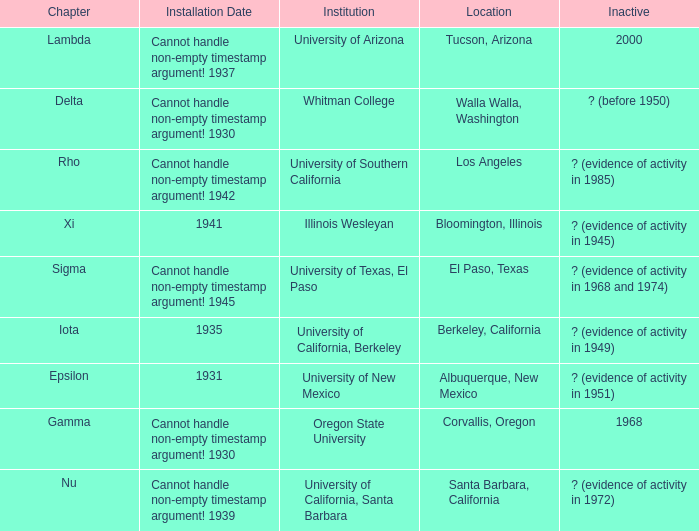Can you give me this table as a dict? {'header': ['Chapter', 'Installation Date', 'Institution', 'Location', 'Inactive'], 'rows': [['Lambda', 'Cannot handle non-empty timestamp argument! 1937', 'University of Arizona', 'Tucson, Arizona', '2000'], ['Delta', 'Cannot handle non-empty timestamp argument! 1930', 'Whitman College', 'Walla Walla, Washington', '? (before 1950)'], ['Rho', 'Cannot handle non-empty timestamp argument! 1942', 'University of Southern California', 'Los Angeles', '? (evidence of activity in 1985)'], ['Xi', '1941', 'Illinois Wesleyan', 'Bloomington, Illinois', '? (evidence of activity in 1945)'], ['Sigma', 'Cannot handle non-empty timestamp argument! 1945', 'University of Texas, El Paso', 'El Paso, Texas', '? (evidence of activity in 1968 and 1974)'], ['Iota', '1935', 'University of California, Berkeley', 'Berkeley, California', '? (evidence of activity in 1949)'], ['Epsilon', '1931', 'University of New Mexico', 'Albuquerque, New Mexico', '? (evidence of activity in 1951)'], ['Gamma', 'Cannot handle non-empty timestamp argument! 1930', 'Oregon State University', 'Corvallis, Oregon', '1968'], ['Nu', 'Cannot handle non-empty timestamp argument! 1939', 'University of California, Santa Barbara', 'Santa Barbara, California', '? (evidence of activity in 1972)']]} What was the setup date in el paso, texas? Cannot handle non-empty timestamp argument! 1945. 